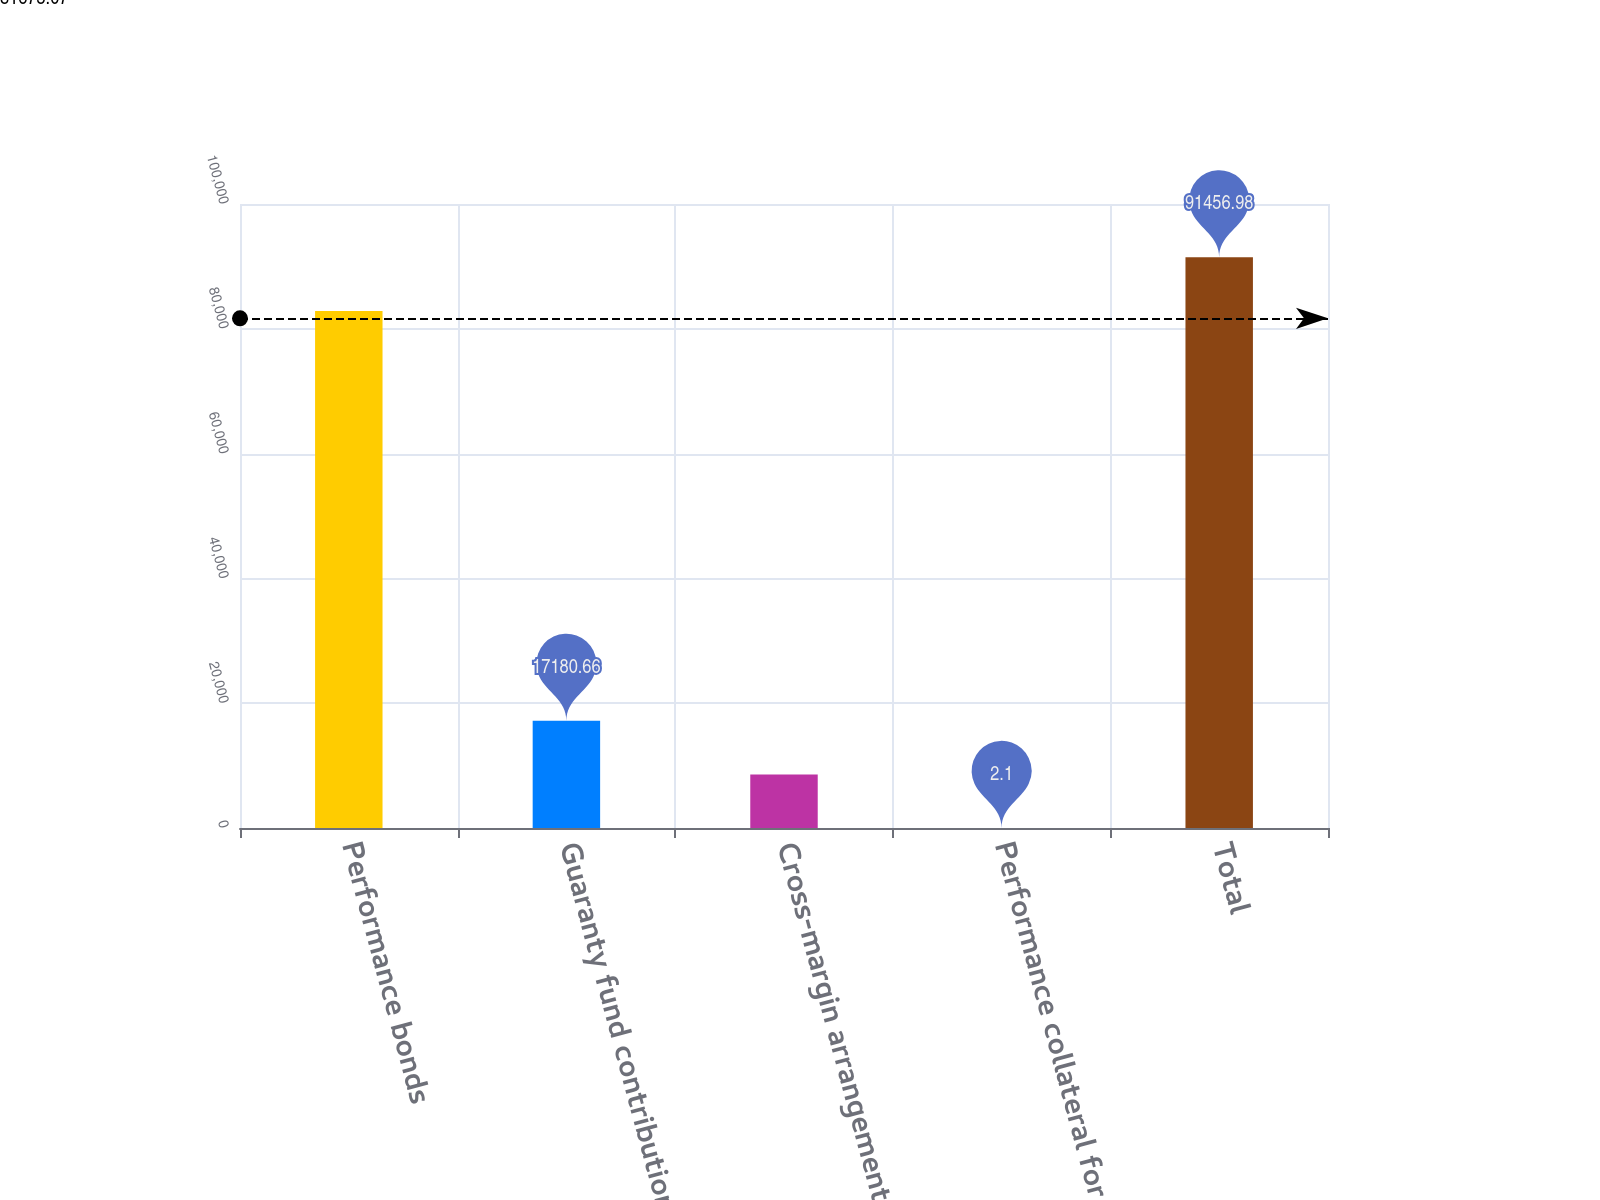<chart> <loc_0><loc_0><loc_500><loc_500><bar_chart><fcel>Performance bonds<fcel>Guaranty fund contributions<fcel>Cross-margin arrangements<fcel>Performance collateral for<fcel>Total<nl><fcel>82867.7<fcel>17180.7<fcel>8591.38<fcel>2.1<fcel>91457<nl></chart> 